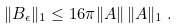<formula> <loc_0><loc_0><loc_500><loc_500>\| B _ { \epsilon } \| _ { 1 } \leq 1 6 \pi \| A \| \, \| A \| _ { 1 } \, .</formula> 